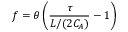Convert formula to latex. <formula><loc_0><loc_0><loc_500><loc_500>f = \theta \left ( \frac { \tau } { L / ( 2 C _ { A } ) } - 1 \right )</formula> 